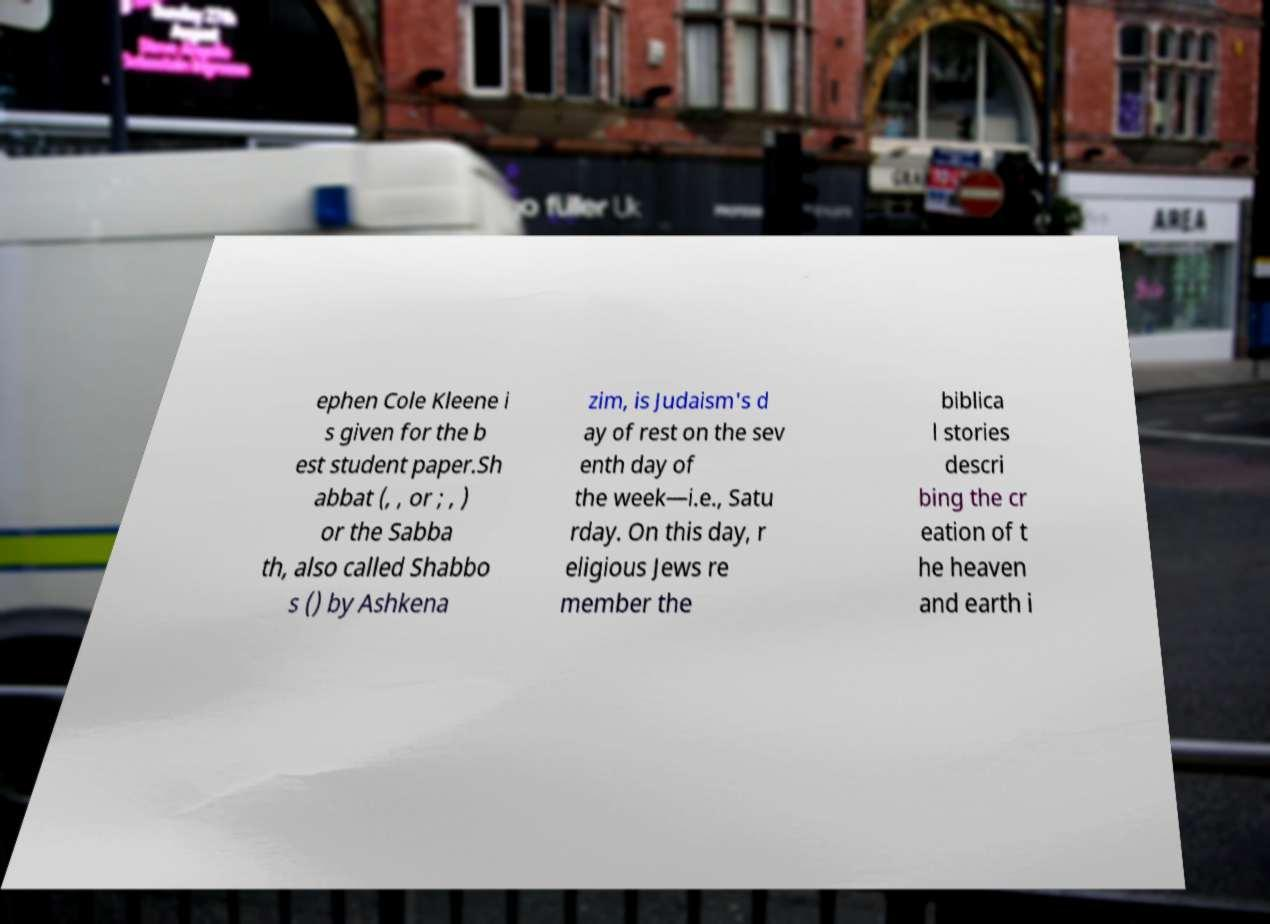Please read and relay the text visible in this image. What does it say? ephen Cole Kleene i s given for the b est student paper.Sh abbat (, , or ; , ) or the Sabba th, also called Shabbo s () by Ashkena zim, is Judaism's d ay of rest on the sev enth day of the week—i.e., Satu rday. On this day, r eligious Jews re member the biblica l stories descri bing the cr eation of t he heaven and earth i 